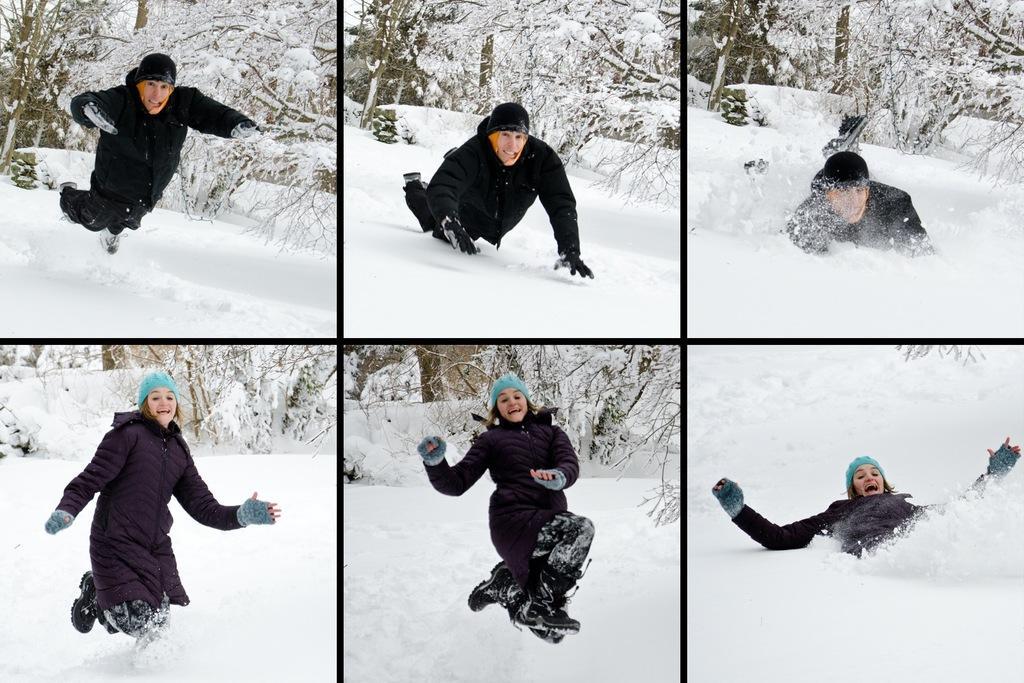Could you give a brief overview of what you see in this image? In the image there is a collage photos of a lady and a man with black jacket. There is snow on the ground. Behind them there are trees covered with snow. They are running and falling on the snow. 